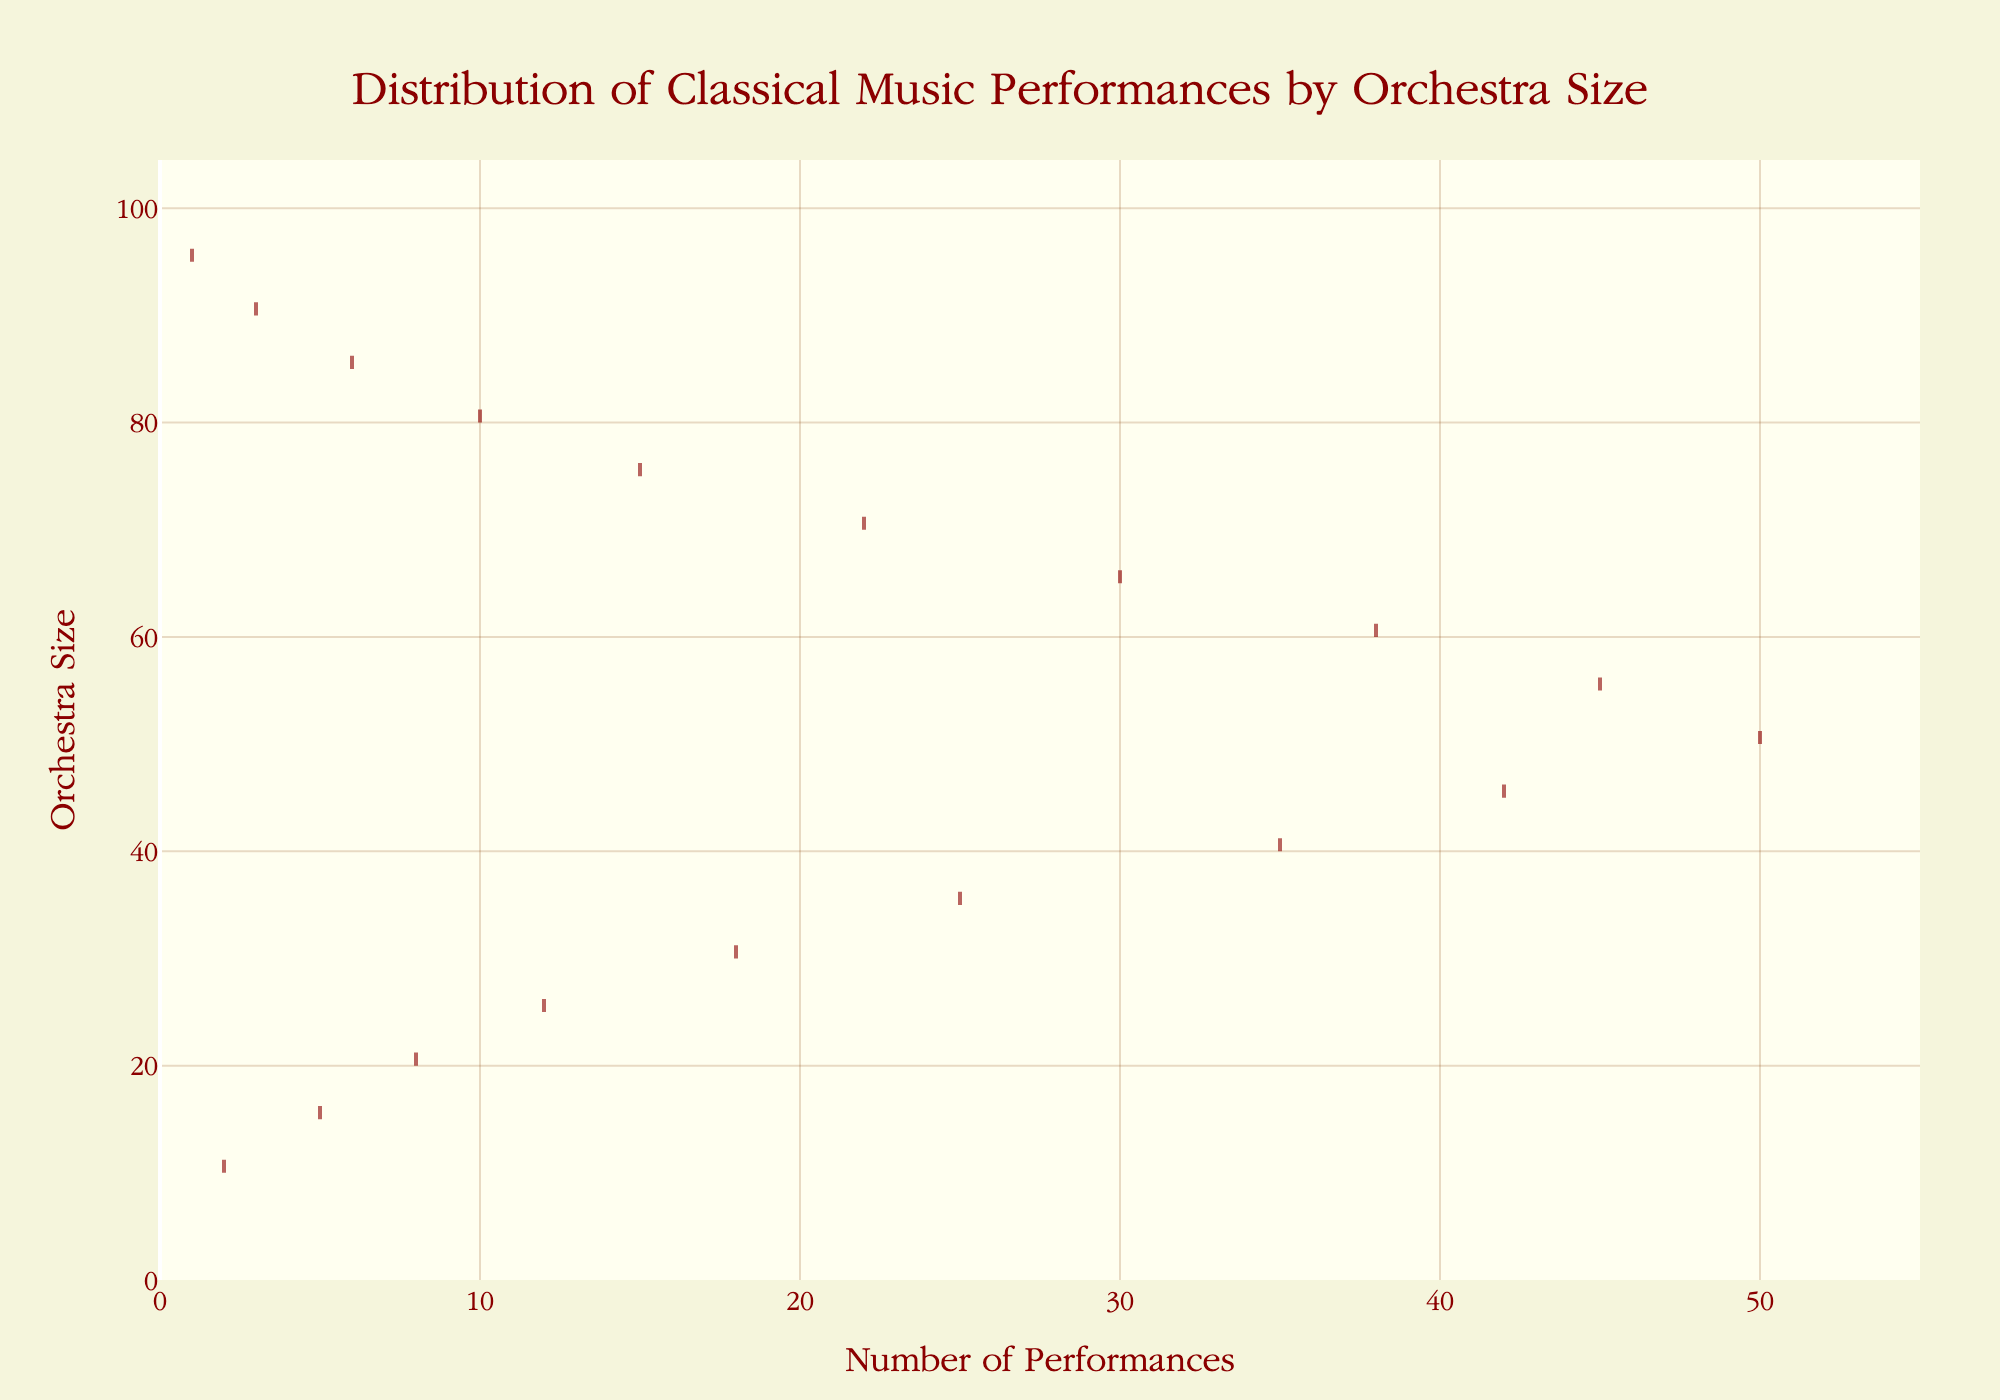What is the maximum number of performances noted in the dataset? The thickest part of the plot represents the highest number of performances. Looking at the x-axis range, we can see a peak around 50 performances.
Answer: 50 What is the smallest orchestra size with any performances? The smallest value on the y-axis where the plot starts is 10.
Answer: 10 At what orchestra size do the performances peak? The peak of performances is at the thickest and most filled area along the y-axis at the value of 50 orchestra size.
Answer: 50 How does the number of performances change as the orchestra size increases from 10 to 50? From the figure, moving from 10 to 50 on the y-axis, the plot widens, indicating an increase in performances. The peak is around 50, showing a rise in the number of performances as orchestra size increases.
Answer: Increases Compare the number of performances at orchestra sizes of 30 and 70. Which has more performances? Observing the plot, the width around 30 is significantly larger compared to 70. Therefore, 30 has more performances than 70.
Answer: 30 What's the general trend in performances as orchestra size increases beyond 50? After the peak at 50, the density thins out gradually, signifying a decrease in the number of performances as the orchestra size increases further.
Answer: Decreases Is there a notable dip in performances at any specific orchestra size? The plot reveals a dip at 55, where the density slightly decreases before stabilizing again.
Answer: 55 What orchestra sizes have the least number of performances? The plot demonstrates that the orchestra sizes 90 and 95 have the least density, indicating the least number of performances.
Answer: 90 and 95 What is the range of orchestra sizes presented in the figure? The figure displays orchestra sizes ranging from 10 to 95.
Answer: 10 to 95 